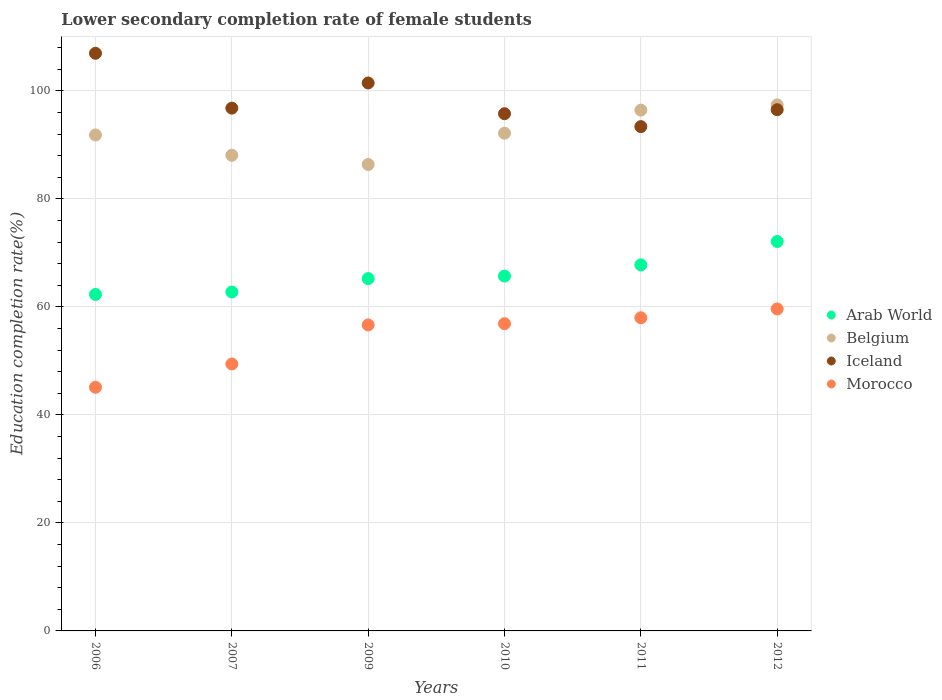What is the lower secondary completion rate of female students in Iceland in 2010?
Ensure brevity in your answer.  95.79. Across all years, what is the maximum lower secondary completion rate of female students in Morocco?
Ensure brevity in your answer.  59.63. Across all years, what is the minimum lower secondary completion rate of female students in Morocco?
Offer a very short reply. 45.13. What is the total lower secondary completion rate of female students in Iceland in the graph?
Your answer should be very brief. 590.99. What is the difference between the lower secondary completion rate of female students in Morocco in 2010 and that in 2012?
Provide a succinct answer. -2.73. What is the difference between the lower secondary completion rate of female students in Belgium in 2006 and the lower secondary completion rate of female students in Morocco in 2012?
Offer a terse response. 32.22. What is the average lower secondary completion rate of female students in Belgium per year?
Your answer should be very brief. 92.06. In the year 2007, what is the difference between the lower secondary completion rate of female students in Arab World and lower secondary completion rate of female students in Iceland?
Ensure brevity in your answer.  -34.06. In how many years, is the lower secondary completion rate of female students in Belgium greater than 8 %?
Keep it short and to the point. 6. What is the ratio of the lower secondary completion rate of female students in Iceland in 2006 to that in 2009?
Keep it short and to the point. 1.05. What is the difference between the highest and the second highest lower secondary completion rate of female students in Morocco?
Offer a very short reply. 1.63. What is the difference between the highest and the lowest lower secondary completion rate of female students in Iceland?
Your response must be concise. 13.58. Is the sum of the lower secondary completion rate of female students in Morocco in 2007 and 2010 greater than the maximum lower secondary completion rate of female students in Belgium across all years?
Keep it short and to the point. Yes. Does the lower secondary completion rate of female students in Morocco monotonically increase over the years?
Your response must be concise. Yes. Is the lower secondary completion rate of female students in Morocco strictly greater than the lower secondary completion rate of female students in Belgium over the years?
Offer a terse response. No. Is the lower secondary completion rate of female students in Belgium strictly less than the lower secondary completion rate of female students in Morocco over the years?
Give a very brief answer. No. How many years are there in the graph?
Provide a short and direct response. 6. What is the difference between two consecutive major ticks on the Y-axis?
Give a very brief answer. 20. How many legend labels are there?
Offer a terse response. 4. How are the legend labels stacked?
Offer a very short reply. Vertical. What is the title of the graph?
Provide a succinct answer. Lower secondary completion rate of female students. Does "Luxembourg" appear as one of the legend labels in the graph?
Make the answer very short. No. What is the label or title of the X-axis?
Make the answer very short. Years. What is the label or title of the Y-axis?
Make the answer very short. Education completion rate(%). What is the Education completion rate(%) in Arab World in 2006?
Provide a succinct answer. 62.31. What is the Education completion rate(%) of Belgium in 2006?
Provide a succinct answer. 91.85. What is the Education completion rate(%) in Iceland in 2006?
Give a very brief answer. 106.98. What is the Education completion rate(%) of Morocco in 2006?
Provide a succinct answer. 45.13. What is the Education completion rate(%) of Arab World in 2007?
Your answer should be compact. 62.76. What is the Education completion rate(%) of Belgium in 2007?
Your response must be concise. 88.09. What is the Education completion rate(%) of Iceland in 2007?
Provide a succinct answer. 96.82. What is the Education completion rate(%) of Morocco in 2007?
Your response must be concise. 49.44. What is the Education completion rate(%) in Arab World in 2009?
Your answer should be compact. 65.25. What is the Education completion rate(%) in Belgium in 2009?
Offer a terse response. 86.38. What is the Education completion rate(%) in Iceland in 2009?
Your response must be concise. 101.48. What is the Education completion rate(%) of Morocco in 2009?
Your answer should be very brief. 56.67. What is the Education completion rate(%) of Arab World in 2010?
Offer a very short reply. 65.71. What is the Education completion rate(%) of Belgium in 2010?
Your response must be concise. 92.18. What is the Education completion rate(%) in Iceland in 2010?
Ensure brevity in your answer.  95.79. What is the Education completion rate(%) of Morocco in 2010?
Your answer should be very brief. 56.9. What is the Education completion rate(%) in Arab World in 2011?
Make the answer very short. 67.79. What is the Education completion rate(%) in Belgium in 2011?
Your answer should be compact. 96.45. What is the Education completion rate(%) in Iceland in 2011?
Make the answer very short. 93.4. What is the Education completion rate(%) in Morocco in 2011?
Offer a terse response. 57.99. What is the Education completion rate(%) of Arab World in 2012?
Provide a short and direct response. 72.12. What is the Education completion rate(%) of Belgium in 2012?
Offer a very short reply. 97.42. What is the Education completion rate(%) of Iceland in 2012?
Make the answer very short. 96.53. What is the Education completion rate(%) of Morocco in 2012?
Your response must be concise. 59.63. Across all years, what is the maximum Education completion rate(%) of Arab World?
Offer a very short reply. 72.12. Across all years, what is the maximum Education completion rate(%) in Belgium?
Offer a terse response. 97.42. Across all years, what is the maximum Education completion rate(%) in Iceland?
Provide a succinct answer. 106.98. Across all years, what is the maximum Education completion rate(%) in Morocco?
Provide a short and direct response. 59.63. Across all years, what is the minimum Education completion rate(%) in Arab World?
Your response must be concise. 62.31. Across all years, what is the minimum Education completion rate(%) in Belgium?
Give a very brief answer. 86.38. Across all years, what is the minimum Education completion rate(%) in Iceland?
Your response must be concise. 93.4. Across all years, what is the minimum Education completion rate(%) in Morocco?
Make the answer very short. 45.13. What is the total Education completion rate(%) in Arab World in the graph?
Ensure brevity in your answer.  395.95. What is the total Education completion rate(%) in Belgium in the graph?
Your answer should be very brief. 552.37. What is the total Education completion rate(%) of Iceland in the graph?
Offer a terse response. 590.99. What is the total Education completion rate(%) in Morocco in the graph?
Offer a very short reply. 325.75. What is the difference between the Education completion rate(%) in Arab World in 2006 and that in 2007?
Provide a succinct answer. -0.45. What is the difference between the Education completion rate(%) in Belgium in 2006 and that in 2007?
Offer a terse response. 3.76. What is the difference between the Education completion rate(%) in Iceland in 2006 and that in 2007?
Your response must be concise. 10.16. What is the difference between the Education completion rate(%) of Morocco in 2006 and that in 2007?
Provide a short and direct response. -4.31. What is the difference between the Education completion rate(%) in Arab World in 2006 and that in 2009?
Your answer should be compact. -2.94. What is the difference between the Education completion rate(%) of Belgium in 2006 and that in 2009?
Your answer should be very brief. 5.47. What is the difference between the Education completion rate(%) in Iceland in 2006 and that in 2009?
Your response must be concise. 5.5. What is the difference between the Education completion rate(%) of Morocco in 2006 and that in 2009?
Keep it short and to the point. -11.54. What is the difference between the Education completion rate(%) in Arab World in 2006 and that in 2010?
Provide a short and direct response. -3.4. What is the difference between the Education completion rate(%) of Belgium in 2006 and that in 2010?
Make the answer very short. -0.33. What is the difference between the Education completion rate(%) of Iceland in 2006 and that in 2010?
Your answer should be compact. 11.19. What is the difference between the Education completion rate(%) in Morocco in 2006 and that in 2010?
Keep it short and to the point. -11.77. What is the difference between the Education completion rate(%) in Arab World in 2006 and that in 2011?
Your answer should be compact. -5.48. What is the difference between the Education completion rate(%) in Belgium in 2006 and that in 2011?
Give a very brief answer. -4.6. What is the difference between the Education completion rate(%) in Iceland in 2006 and that in 2011?
Offer a very short reply. 13.58. What is the difference between the Education completion rate(%) in Morocco in 2006 and that in 2011?
Offer a terse response. -12.87. What is the difference between the Education completion rate(%) of Arab World in 2006 and that in 2012?
Your answer should be compact. -9.81. What is the difference between the Education completion rate(%) of Belgium in 2006 and that in 2012?
Offer a very short reply. -5.58. What is the difference between the Education completion rate(%) in Iceland in 2006 and that in 2012?
Give a very brief answer. 10.45. What is the difference between the Education completion rate(%) of Morocco in 2006 and that in 2012?
Your answer should be compact. -14.5. What is the difference between the Education completion rate(%) of Arab World in 2007 and that in 2009?
Give a very brief answer. -2.49. What is the difference between the Education completion rate(%) in Belgium in 2007 and that in 2009?
Ensure brevity in your answer.  1.71. What is the difference between the Education completion rate(%) in Iceland in 2007 and that in 2009?
Ensure brevity in your answer.  -4.66. What is the difference between the Education completion rate(%) of Morocco in 2007 and that in 2009?
Your answer should be compact. -7.23. What is the difference between the Education completion rate(%) of Arab World in 2007 and that in 2010?
Provide a short and direct response. -2.95. What is the difference between the Education completion rate(%) of Belgium in 2007 and that in 2010?
Make the answer very short. -4.09. What is the difference between the Education completion rate(%) of Iceland in 2007 and that in 2010?
Your response must be concise. 1.03. What is the difference between the Education completion rate(%) in Morocco in 2007 and that in 2010?
Ensure brevity in your answer.  -7.46. What is the difference between the Education completion rate(%) in Arab World in 2007 and that in 2011?
Provide a short and direct response. -5.03. What is the difference between the Education completion rate(%) in Belgium in 2007 and that in 2011?
Your answer should be very brief. -8.37. What is the difference between the Education completion rate(%) in Iceland in 2007 and that in 2011?
Give a very brief answer. 3.42. What is the difference between the Education completion rate(%) in Morocco in 2007 and that in 2011?
Your answer should be very brief. -8.55. What is the difference between the Education completion rate(%) of Arab World in 2007 and that in 2012?
Your answer should be compact. -9.36. What is the difference between the Education completion rate(%) of Belgium in 2007 and that in 2012?
Your response must be concise. -9.34. What is the difference between the Education completion rate(%) of Iceland in 2007 and that in 2012?
Your answer should be compact. 0.29. What is the difference between the Education completion rate(%) of Morocco in 2007 and that in 2012?
Your answer should be compact. -10.19. What is the difference between the Education completion rate(%) of Arab World in 2009 and that in 2010?
Provide a short and direct response. -0.46. What is the difference between the Education completion rate(%) of Belgium in 2009 and that in 2010?
Offer a very short reply. -5.8. What is the difference between the Education completion rate(%) in Iceland in 2009 and that in 2010?
Make the answer very short. 5.7. What is the difference between the Education completion rate(%) in Morocco in 2009 and that in 2010?
Provide a short and direct response. -0.23. What is the difference between the Education completion rate(%) of Arab World in 2009 and that in 2011?
Your response must be concise. -2.54. What is the difference between the Education completion rate(%) of Belgium in 2009 and that in 2011?
Provide a short and direct response. -10.07. What is the difference between the Education completion rate(%) of Iceland in 2009 and that in 2011?
Make the answer very short. 8.08. What is the difference between the Education completion rate(%) of Morocco in 2009 and that in 2011?
Your answer should be compact. -1.32. What is the difference between the Education completion rate(%) of Arab World in 2009 and that in 2012?
Ensure brevity in your answer.  -6.87. What is the difference between the Education completion rate(%) in Belgium in 2009 and that in 2012?
Make the answer very short. -11.04. What is the difference between the Education completion rate(%) of Iceland in 2009 and that in 2012?
Offer a very short reply. 4.95. What is the difference between the Education completion rate(%) in Morocco in 2009 and that in 2012?
Provide a succinct answer. -2.96. What is the difference between the Education completion rate(%) of Arab World in 2010 and that in 2011?
Keep it short and to the point. -2.08. What is the difference between the Education completion rate(%) of Belgium in 2010 and that in 2011?
Offer a terse response. -4.28. What is the difference between the Education completion rate(%) in Iceland in 2010 and that in 2011?
Ensure brevity in your answer.  2.39. What is the difference between the Education completion rate(%) of Morocco in 2010 and that in 2011?
Offer a terse response. -1.09. What is the difference between the Education completion rate(%) in Arab World in 2010 and that in 2012?
Offer a terse response. -6.41. What is the difference between the Education completion rate(%) in Belgium in 2010 and that in 2012?
Provide a short and direct response. -5.25. What is the difference between the Education completion rate(%) in Iceland in 2010 and that in 2012?
Offer a very short reply. -0.74. What is the difference between the Education completion rate(%) of Morocco in 2010 and that in 2012?
Keep it short and to the point. -2.73. What is the difference between the Education completion rate(%) in Arab World in 2011 and that in 2012?
Offer a terse response. -4.33. What is the difference between the Education completion rate(%) in Belgium in 2011 and that in 2012?
Ensure brevity in your answer.  -0.97. What is the difference between the Education completion rate(%) of Iceland in 2011 and that in 2012?
Offer a terse response. -3.13. What is the difference between the Education completion rate(%) in Morocco in 2011 and that in 2012?
Keep it short and to the point. -1.63. What is the difference between the Education completion rate(%) of Arab World in 2006 and the Education completion rate(%) of Belgium in 2007?
Your answer should be compact. -25.77. What is the difference between the Education completion rate(%) in Arab World in 2006 and the Education completion rate(%) in Iceland in 2007?
Give a very brief answer. -34.51. What is the difference between the Education completion rate(%) in Arab World in 2006 and the Education completion rate(%) in Morocco in 2007?
Offer a terse response. 12.87. What is the difference between the Education completion rate(%) of Belgium in 2006 and the Education completion rate(%) of Iceland in 2007?
Offer a terse response. -4.97. What is the difference between the Education completion rate(%) of Belgium in 2006 and the Education completion rate(%) of Morocco in 2007?
Provide a succinct answer. 42.41. What is the difference between the Education completion rate(%) in Iceland in 2006 and the Education completion rate(%) in Morocco in 2007?
Provide a succinct answer. 57.54. What is the difference between the Education completion rate(%) in Arab World in 2006 and the Education completion rate(%) in Belgium in 2009?
Give a very brief answer. -24.07. What is the difference between the Education completion rate(%) of Arab World in 2006 and the Education completion rate(%) of Iceland in 2009?
Ensure brevity in your answer.  -39.17. What is the difference between the Education completion rate(%) of Arab World in 2006 and the Education completion rate(%) of Morocco in 2009?
Give a very brief answer. 5.64. What is the difference between the Education completion rate(%) in Belgium in 2006 and the Education completion rate(%) in Iceland in 2009?
Keep it short and to the point. -9.63. What is the difference between the Education completion rate(%) in Belgium in 2006 and the Education completion rate(%) in Morocco in 2009?
Provide a short and direct response. 35.18. What is the difference between the Education completion rate(%) in Iceland in 2006 and the Education completion rate(%) in Morocco in 2009?
Ensure brevity in your answer.  50.31. What is the difference between the Education completion rate(%) in Arab World in 2006 and the Education completion rate(%) in Belgium in 2010?
Make the answer very short. -29.86. What is the difference between the Education completion rate(%) in Arab World in 2006 and the Education completion rate(%) in Iceland in 2010?
Your answer should be very brief. -33.47. What is the difference between the Education completion rate(%) in Arab World in 2006 and the Education completion rate(%) in Morocco in 2010?
Your answer should be compact. 5.41. What is the difference between the Education completion rate(%) of Belgium in 2006 and the Education completion rate(%) of Iceland in 2010?
Your answer should be compact. -3.94. What is the difference between the Education completion rate(%) of Belgium in 2006 and the Education completion rate(%) of Morocco in 2010?
Your answer should be compact. 34.95. What is the difference between the Education completion rate(%) in Iceland in 2006 and the Education completion rate(%) in Morocco in 2010?
Your answer should be very brief. 50.08. What is the difference between the Education completion rate(%) of Arab World in 2006 and the Education completion rate(%) of Belgium in 2011?
Make the answer very short. -34.14. What is the difference between the Education completion rate(%) of Arab World in 2006 and the Education completion rate(%) of Iceland in 2011?
Offer a terse response. -31.09. What is the difference between the Education completion rate(%) of Arab World in 2006 and the Education completion rate(%) of Morocco in 2011?
Keep it short and to the point. 4.32. What is the difference between the Education completion rate(%) in Belgium in 2006 and the Education completion rate(%) in Iceland in 2011?
Provide a short and direct response. -1.55. What is the difference between the Education completion rate(%) in Belgium in 2006 and the Education completion rate(%) in Morocco in 2011?
Provide a succinct answer. 33.86. What is the difference between the Education completion rate(%) of Iceland in 2006 and the Education completion rate(%) of Morocco in 2011?
Your answer should be very brief. 48.99. What is the difference between the Education completion rate(%) of Arab World in 2006 and the Education completion rate(%) of Belgium in 2012?
Ensure brevity in your answer.  -35.11. What is the difference between the Education completion rate(%) of Arab World in 2006 and the Education completion rate(%) of Iceland in 2012?
Keep it short and to the point. -34.22. What is the difference between the Education completion rate(%) of Arab World in 2006 and the Education completion rate(%) of Morocco in 2012?
Provide a succinct answer. 2.69. What is the difference between the Education completion rate(%) in Belgium in 2006 and the Education completion rate(%) in Iceland in 2012?
Provide a succinct answer. -4.68. What is the difference between the Education completion rate(%) in Belgium in 2006 and the Education completion rate(%) in Morocco in 2012?
Your answer should be compact. 32.22. What is the difference between the Education completion rate(%) in Iceland in 2006 and the Education completion rate(%) in Morocco in 2012?
Your answer should be very brief. 47.35. What is the difference between the Education completion rate(%) in Arab World in 2007 and the Education completion rate(%) in Belgium in 2009?
Give a very brief answer. -23.62. What is the difference between the Education completion rate(%) of Arab World in 2007 and the Education completion rate(%) of Iceland in 2009?
Offer a very short reply. -38.72. What is the difference between the Education completion rate(%) in Arab World in 2007 and the Education completion rate(%) in Morocco in 2009?
Offer a very short reply. 6.09. What is the difference between the Education completion rate(%) in Belgium in 2007 and the Education completion rate(%) in Iceland in 2009?
Provide a short and direct response. -13.4. What is the difference between the Education completion rate(%) in Belgium in 2007 and the Education completion rate(%) in Morocco in 2009?
Give a very brief answer. 31.42. What is the difference between the Education completion rate(%) of Iceland in 2007 and the Education completion rate(%) of Morocco in 2009?
Ensure brevity in your answer.  40.15. What is the difference between the Education completion rate(%) in Arab World in 2007 and the Education completion rate(%) in Belgium in 2010?
Offer a terse response. -29.41. What is the difference between the Education completion rate(%) of Arab World in 2007 and the Education completion rate(%) of Iceland in 2010?
Offer a terse response. -33.02. What is the difference between the Education completion rate(%) of Arab World in 2007 and the Education completion rate(%) of Morocco in 2010?
Your answer should be very brief. 5.86. What is the difference between the Education completion rate(%) in Belgium in 2007 and the Education completion rate(%) in Iceland in 2010?
Make the answer very short. -7.7. What is the difference between the Education completion rate(%) of Belgium in 2007 and the Education completion rate(%) of Morocco in 2010?
Your answer should be compact. 31.19. What is the difference between the Education completion rate(%) of Iceland in 2007 and the Education completion rate(%) of Morocco in 2010?
Keep it short and to the point. 39.92. What is the difference between the Education completion rate(%) of Arab World in 2007 and the Education completion rate(%) of Belgium in 2011?
Provide a short and direct response. -33.69. What is the difference between the Education completion rate(%) of Arab World in 2007 and the Education completion rate(%) of Iceland in 2011?
Your response must be concise. -30.64. What is the difference between the Education completion rate(%) of Arab World in 2007 and the Education completion rate(%) of Morocco in 2011?
Keep it short and to the point. 4.77. What is the difference between the Education completion rate(%) in Belgium in 2007 and the Education completion rate(%) in Iceland in 2011?
Offer a terse response. -5.31. What is the difference between the Education completion rate(%) in Belgium in 2007 and the Education completion rate(%) in Morocco in 2011?
Offer a very short reply. 30.09. What is the difference between the Education completion rate(%) of Iceland in 2007 and the Education completion rate(%) of Morocco in 2011?
Your answer should be very brief. 38.83. What is the difference between the Education completion rate(%) in Arab World in 2007 and the Education completion rate(%) in Belgium in 2012?
Make the answer very short. -34.66. What is the difference between the Education completion rate(%) in Arab World in 2007 and the Education completion rate(%) in Iceland in 2012?
Offer a terse response. -33.76. What is the difference between the Education completion rate(%) of Arab World in 2007 and the Education completion rate(%) of Morocco in 2012?
Make the answer very short. 3.14. What is the difference between the Education completion rate(%) in Belgium in 2007 and the Education completion rate(%) in Iceland in 2012?
Your answer should be very brief. -8.44. What is the difference between the Education completion rate(%) in Belgium in 2007 and the Education completion rate(%) in Morocco in 2012?
Offer a terse response. 28.46. What is the difference between the Education completion rate(%) of Iceland in 2007 and the Education completion rate(%) of Morocco in 2012?
Offer a terse response. 37.19. What is the difference between the Education completion rate(%) in Arab World in 2009 and the Education completion rate(%) in Belgium in 2010?
Your response must be concise. -26.93. What is the difference between the Education completion rate(%) of Arab World in 2009 and the Education completion rate(%) of Iceland in 2010?
Your response must be concise. -30.54. What is the difference between the Education completion rate(%) of Arab World in 2009 and the Education completion rate(%) of Morocco in 2010?
Provide a succinct answer. 8.35. What is the difference between the Education completion rate(%) of Belgium in 2009 and the Education completion rate(%) of Iceland in 2010?
Give a very brief answer. -9.41. What is the difference between the Education completion rate(%) of Belgium in 2009 and the Education completion rate(%) of Morocco in 2010?
Offer a terse response. 29.48. What is the difference between the Education completion rate(%) in Iceland in 2009 and the Education completion rate(%) in Morocco in 2010?
Give a very brief answer. 44.58. What is the difference between the Education completion rate(%) of Arab World in 2009 and the Education completion rate(%) of Belgium in 2011?
Offer a very short reply. -31.2. What is the difference between the Education completion rate(%) in Arab World in 2009 and the Education completion rate(%) in Iceland in 2011?
Keep it short and to the point. -28.15. What is the difference between the Education completion rate(%) of Arab World in 2009 and the Education completion rate(%) of Morocco in 2011?
Keep it short and to the point. 7.26. What is the difference between the Education completion rate(%) of Belgium in 2009 and the Education completion rate(%) of Iceland in 2011?
Your answer should be very brief. -7.02. What is the difference between the Education completion rate(%) in Belgium in 2009 and the Education completion rate(%) in Morocco in 2011?
Give a very brief answer. 28.39. What is the difference between the Education completion rate(%) in Iceland in 2009 and the Education completion rate(%) in Morocco in 2011?
Provide a succinct answer. 43.49. What is the difference between the Education completion rate(%) of Arab World in 2009 and the Education completion rate(%) of Belgium in 2012?
Keep it short and to the point. -32.17. What is the difference between the Education completion rate(%) in Arab World in 2009 and the Education completion rate(%) in Iceland in 2012?
Make the answer very short. -31.28. What is the difference between the Education completion rate(%) of Arab World in 2009 and the Education completion rate(%) of Morocco in 2012?
Offer a very short reply. 5.62. What is the difference between the Education completion rate(%) in Belgium in 2009 and the Education completion rate(%) in Iceland in 2012?
Make the answer very short. -10.15. What is the difference between the Education completion rate(%) in Belgium in 2009 and the Education completion rate(%) in Morocco in 2012?
Provide a short and direct response. 26.75. What is the difference between the Education completion rate(%) of Iceland in 2009 and the Education completion rate(%) of Morocco in 2012?
Your answer should be compact. 41.85. What is the difference between the Education completion rate(%) in Arab World in 2010 and the Education completion rate(%) in Belgium in 2011?
Keep it short and to the point. -30.74. What is the difference between the Education completion rate(%) in Arab World in 2010 and the Education completion rate(%) in Iceland in 2011?
Your response must be concise. -27.69. What is the difference between the Education completion rate(%) in Arab World in 2010 and the Education completion rate(%) in Morocco in 2011?
Give a very brief answer. 7.72. What is the difference between the Education completion rate(%) in Belgium in 2010 and the Education completion rate(%) in Iceland in 2011?
Provide a succinct answer. -1.22. What is the difference between the Education completion rate(%) in Belgium in 2010 and the Education completion rate(%) in Morocco in 2011?
Ensure brevity in your answer.  34.18. What is the difference between the Education completion rate(%) of Iceland in 2010 and the Education completion rate(%) of Morocco in 2011?
Give a very brief answer. 37.79. What is the difference between the Education completion rate(%) in Arab World in 2010 and the Education completion rate(%) in Belgium in 2012?
Offer a terse response. -31.71. What is the difference between the Education completion rate(%) of Arab World in 2010 and the Education completion rate(%) of Iceland in 2012?
Give a very brief answer. -30.82. What is the difference between the Education completion rate(%) in Arab World in 2010 and the Education completion rate(%) in Morocco in 2012?
Ensure brevity in your answer.  6.08. What is the difference between the Education completion rate(%) in Belgium in 2010 and the Education completion rate(%) in Iceland in 2012?
Offer a very short reply. -4.35. What is the difference between the Education completion rate(%) of Belgium in 2010 and the Education completion rate(%) of Morocco in 2012?
Make the answer very short. 32.55. What is the difference between the Education completion rate(%) in Iceland in 2010 and the Education completion rate(%) in Morocco in 2012?
Ensure brevity in your answer.  36.16. What is the difference between the Education completion rate(%) of Arab World in 2011 and the Education completion rate(%) of Belgium in 2012?
Provide a short and direct response. -29.63. What is the difference between the Education completion rate(%) of Arab World in 2011 and the Education completion rate(%) of Iceland in 2012?
Make the answer very short. -28.74. What is the difference between the Education completion rate(%) of Arab World in 2011 and the Education completion rate(%) of Morocco in 2012?
Offer a terse response. 8.16. What is the difference between the Education completion rate(%) of Belgium in 2011 and the Education completion rate(%) of Iceland in 2012?
Keep it short and to the point. -0.08. What is the difference between the Education completion rate(%) of Belgium in 2011 and the Education completion rate(%) of Morocco in 2012?
Keep it short and to the point. 36.83. What is the difference between the Education completion rate(%) of Iceland in 2011 and the Education completion rate(%) of Morocco in 2012?
Your answer should be very brief. 33.77. What is the average Education completion rate(%) in Arab World per year?
Make the answer very short. 65.99. What is the average Education completion rate(%) in Belgium per year?
Provide a succinct answer. 92.06. What is the average Education completion rate(%) in Iceland per year?
Provide a succinct answer. 98.5. What is the average Education completion rate(%) in Morocco per year?
Ensure brevity in your answer.  54.29. In the year 2006, what is the difference between the Education completion rate(%) of Arab World and Education completion rate(%) of Belgium?
Provide a short and direct response. -29.54. In the year 2006, what is the difference between the Education completion rate(%) in Arab World and Education completion rate(%) in Iceland?
Your response must be concise. -44.67. In the year 2006, what is the difference between the Education completion rate(%) of Arab World and Education completion rate(%) of Morocco?
Ensure brevity in your answer.  17.19. In the year 2006, what is the difference between the Education completion rate(%) of Belgium and Education completion rate(%) of Iceland?
Ensure brevity in your answer.  -15.13. In the year 2006, what is the difference between the Education completion rate(%) in Belgium and Education completion rate(%) in Morocco?
Ensure brevity in your answer.  46.72. In the year 2006, what is the difference between the Education completion rate(%) in Iceland and Education completion rate(%) in Morocco?
Ensure brevity in your answer.  61.85. In the year 2007, what is the difference between the Education completion rate(%) of Arab World and Education completion rate(%) of Belgium?
Your response must be concise. -25.32. In the year 2007, what is the difference between the Education completion rate(%) in Arab World and Education completion rate(%) in Iceland?
Offer a very short reply. -34.06. In the year 2007, what is the difference between the Education completion rate(%) of Arab World and Education completion rate(%) of Morocco?
Ensure brevity in your answer.  13.32. In the year 2007, what is the difference between the Education completion rate(%) of Belgium and Education completion rate(%) of Iceland?
Keep it short and to the point. -8.73. In the year 2007, what is the difference between the Education completion rate(%) of Belgium and Education completion rate(%) of Morocco?
Keep it short and to the point. 38.65. In the year 2007, what is the difference between the Education completion rate(%) in Iceland and Education completion rate(%) in Morocco?
Your response must be concise. 47.38. In the year 2009, what is the difference between the Education completion rate(%) in Arab World and Education completion rate(%) in Belgium?
Give a very brief answer. -21.13. In the year 2009, what is the difference between the Education completion rate(%) of Arab World and Education completion rate(%) of Iceland?
Your answer should be compact. -36.23. In the year 2009, what is the difference between the Education completion rate(%) in Arab World and Education completion rate(%) in Morocco?
Provide a short and direct response. 8.58. In the year 2009, what is the difference between the Education completion rate(%) in Belgium and Education completion rate(%) in Iceland?
Provide a short and direct response. -15.1. In the year 2009, what is the difference between the Education completion rate(%) in Belgium and Education completion rate(%) in Morocco?
Your answer should be compact. 29.71. In the year 2009, what is the difference between the Education completion rate(%) of Iceland and Education completion rate(%) of Morocco?
Your answer should be very brief. 44.81. In the year 2010, what is the difference between the Education completion rate(%) in Arab World and Education completion rate(%) in Belgium?
Give a very brief answer. -26.46. In the year 2010, what is the difference between the Education completion rate(%) in Arab World and Education completion rate(%) in Iceland?
Ensure brevity in your answer.  -30.07. In the year 2010, what is the difference between the Education completion rate(%) of Arab World and Education completion rate(%) of Morocco?
Make the answer very short. 8.81. In the year 2010, what is the difference between the Education completion rate(%) of Belgium and Education completion rate(%) of Iceland?
Your answer should be compact. -3.61. In the year 2010, what is the difference between the Education completion rate(%) of Belgium and Education completion rate(%) of Morocco?
Provide a short and direct response. 35.28. In the year 2010, what is the difference between the Education completion rate(%) in Iceland and Education completion rate(%) in Morocco?
Provide a short and direct response. 38.89. In the year 2011, what is the difference between the Education completion rate(%) of Arab World and Education completion rate(%) of Belgium?
Your answer should be compact. -28.66. In the year 2011, what is the difference between the Education completion rate(%) in Arab World and Education completion rate(%) in Iceland?
Offer a terse response. -25.61. In the year 2011, what is the difference between the Education completion rate(%) of Arab World and Education completion rate(%) of Morocco?
Make the answer very short. 9.8. In the year 2011, what is the difference between the Education completion rate(%) in Belgium and Education completion rate(%) in Iceland?
Make the answer very short. 3.05. In the year 2011, what is the difference between the Education completion rate(%) of Belgium and Education completion rate(%) of Morocco?
Your answer should be very brief. 38.46. In the year 2011, what is the difference between the Education completion rate(%) of Iceland and Education completion rate(%) of Morocco?
Ensure brevity in your answer.  35.41. In the year 2012, what is the difference between the Education completion rate(%) of Arab World and Education completion rate(%) of Belgium?
Offer a very short reply. -25.3. In the year 2012, what is the difference between the Education completion rate(%) of Arab World and Education completion rate(%) of Iceland?
Give a very brief answer. -24.41. In the year 2012, what is the difference between the Education completion rate(%) of Arab World and Education completion rate(%) of Morocco?
Provide a short and direct response. 12.5. In the year 2012, what is the difference between the Education completion rate(%) of Belgium and Education completion rate(%) of Iceland?
Provide a short and direct response. 0.9. In the year 2012, what is the difference between the Education completion rate(%) of Belgium and Education completion rate(%) of Morocco?
Your answer should be compact. 37.8. In the year 2012, what is the difference between the Education completion rate(%) of Iceland and Education completion rate(%) of Morocco?
Provide a short and direct response. 36.9. What is the ratio of the Education completion rate(%) of Arab World in 2006 to that in 2007?
Your answer should be compact. 0.99. What is the ratio of the Education completion rate(%) in Belgium in 2006 to that in 2007?
Offer a very short reply. 1.04. What is the ratio of the Education completion rate(%) of Iceland in 2006 to that in 2007?
Offer a terse response. 1.1. What is the ratio of the Education completion rate(%) of Morocco in 2006 to that in 2007?
Your response must be concise. 0.91. What is the ratio of the Education completion rate(%) of Arab World in 2006 to that in 2009?
Offer a very short reply. 0.95. What is the ratio of the Education completion rate(%) in Belgium in 2006 to that in 2009?
Give a very brief answer. 1.06. What is the ratio of the Education completion rate(%) of Iceland in 2006 to that in 2009?
Your answer should be very brief. 1.05. What is the ratio of the Education completion rate(%) of Morocco in 2006 to that in 2009?
Keep it short and to the point. 0.8. What is the ratio of the Education completion rate(%) in Arab World in 2006 to that in 2010?
Make the answer very short. 0.95. What is the ratio of the Education completion rate(%) of Iceland in 2006 to that in 2010?
Keep it short and to the point. 1.12. What is the ratio of the Education completion rate(%) of Morocco in 2006 to that in 2010?
Provide a succinct answer. 0.79. What is the ratio of the Education completion rate(%) of Arab World in 2006 to that in 2011?
Offer a very short reply. 0.92. What is the ratio of the Education completion rate(%) in Belgium in 2006 to that in 2011?
Make the answer very short. 0.95. What is the ratio of the Education completion rate(%) of Iceland in 2006 to that in 2011?
Make the answer very short. 1.15. What is the ratio of the Education completion rate(%) of Morocco in 2006 to that in 2011?
Offer a very short reply. 0.78. What is the ratio of the Education completion rate(%) of Arab World in 2006 to that in 2012?
Your answer should be compact. 0.86. What is the ratio of the Education completion rate(%) of Belgium in 2006 to that in 2012?
Ensure brevity in your answer.  0.94. What is the ratio of the Education completion rate(%) in Iceland in 2006 to that in 2012?
Your response must be concise. 1.11. What is the ratio of the Education completion rate(%) of Morocco in 2006 to that in 2012?
Your answer should be very brief. 0.76. What is the ratio of the Education completion rate(%) in Arab World in 2007 to that in 2009?
Provide a succinct answer. 0.96. What is the ratio of the Education completion rate(%) of Belgium in 2007 to that in 2009?
Offer a terse response. 1.02. What is the ratio of the Education completion rate(%) of Iceland in 2007 to that in 2009?
Your response must be concise. 0.95. What is the ratio of the Education completion rate(%) in Morocco in 2007 to that in 2009?
Provide a succinct answer. 0.87. What is the ratio of the Education completion rate(%) of Arab World in 2007 to that in 2010?
Give a very brief answer. 0.96. What is the ratio of the Education completion rate(%) of Belgium in 2007 to that in 2010?
Make the answer very short. 0.96. What is the ratio of the Education completion rate(%) in Iceland in 2007 to that in 2010?
Make the answer very short. 1.01. What is the ratio of the Education completion rate(%) in Morocco in 2007 to that in 2010?
Provide a succinct answer. 0.87. What is the ratio of the Education completion rate(%) in Arab World in 2007 to that in 2011?
Give a very brief answer. 0.93. What is the ratio of the Education completion rate(%) of Belgium in 2007 to that in 2011?
Your response must be concise. 0.91. What is the ratio of the Education completion rate(%) in Iceland in 2007 to that in 2011?
Offer a very short reply. 1.04. What is the ratio of the Education completion rate(%) in Morocco in 2007 to that in 2011?
Your response must be concise. 0.85. What is the ratio of the Education completion rate(%) in Arab World in 2007 to that in 2012?
Your answer should be very brief. 0.87. What is the ratio of the Education completion rate(%) of Belgium in 2007 to that in 2012?
Offer a terse response. 0.9. What is the ratio of the Education completion rate(%) in Iceland in 2007 to that in 2012?
Ensure brevity in your answer.  1. What is the ratio of the Education completion rate(%) in Morocco in 2007 to that in 2012?
Offer a very short reply. 0.83. What is the ratio of the Education completion rate(%) in Belgium in 2009 to that in 2010?
Ensure brevity in your answer.  0.94. What is the ratio of the Education completion rate(%) of Iceland in 2009 to that in 2010?
Give a very brief answer. 1.06. What is the ratio of the Education completion rate(%) of Arab World in 2009 to that in 2011?
Keep it short and to the point. 0.96. What is the ratio of the Education completion rate(%) of Belgium in 2009 to that in 2011?
Your answer should be compact. 0.9. What is the ratio of the Education completion rate(%) in Iceland in 2009 to that in 2011?
Your answer should be compact. 1.09. What is the ratio of the Education completion rate(%) in Morocco in 2009 to that in 2011?
Keep it short and to the point. 0.98. What is the ratio of the Education completion rate(%) of Arab World in 2009 to that in 2012?
Provide a succinct answer. 0.9. What is the ratio of the Education completion rate(%) of Belgium in 2009 to that in 2012?
Make the answer very short. 0.89. What is the ratio of the Education completion rate(%) of Iceland in 2009 to that in 2012?
Your answer should be compact. 1.05. What is the ratio of the Education completion rate(%) of Morocco in 2009 to that in 2012?
Offer a very short reply. 0.95. What is the ratio of the Education completion rate(%) of Arab World in 2010 to that in 2011?
Your response must be concise. 0.97. What is the ratio of the Education completion rate(%) of Belgium in 2010 to that in 2011?
Offer a terse response. 0.96. What is the ratio of the Education completion rate(%) of Iceland in 2010 to that in 2011?
Your answer should be very brief. 1.03. What is the ratio of the Education completion rate(%) of Morocco in 2010 to that in 2011?
Give a very brief answer. 0.98. What is the ratio of the Education completion rate(%) in Arab World in 2010 to that in 2012?
Ensure brevity in your answer.  0.91. What is the ratio of the Education completion rate(%) in Belgium in 2010 to that in 2012?
Offer a very short reply. 0.95. What is the ratio of the Education completion rate(%) in Morocco in 2010 to that in 2012?
Keep it short and to the point. 0.95. What is the ratio of the Education completion rate(%) in Arab World in 2011 to that in 2012?
Offer a terse response. 0.94. What is the ratio of the Education completion rate(%) of Iceland in 2011 to that in 2012?
Your answer should be very brief. 0.97. What is the ratio of the Education completion rate(%) in Morocco in 2011 to that in 2012?
Provide a succinct answer. 0.97. What is the difference between the highest and the second highest Education completion rate(%) in Arab World?
Give a very brief answer. 4.33. What is the difference between the highest and the second highest Education completion rate(%) in Belgium?
Make the answer very short. 0.97. What is the difference between the highest and the second highest Education completion rate(%) of Iceland?
Your response must be concise. 5.5. What is the difference between the highest and the second highest Education completion rate(%) of Morocco?
Provide a short and direct response. 1.63. What is the difference between the highest and the lowest Education completion rate(%) in Arab World?
Give a very brief answer. 9.81. What is the difference between the highest and the lowest Education completion rate(%) of Belgium?
Your response must be concise. 11.04. What is the difference between the highest and the lowest Education completion rate(%) in Iceland?
Your response must be concise. 13.58. What is the difference between the highest and the lowest Education completion rate(%) in Morocco?
Your answer should be very brief. 14.5. 